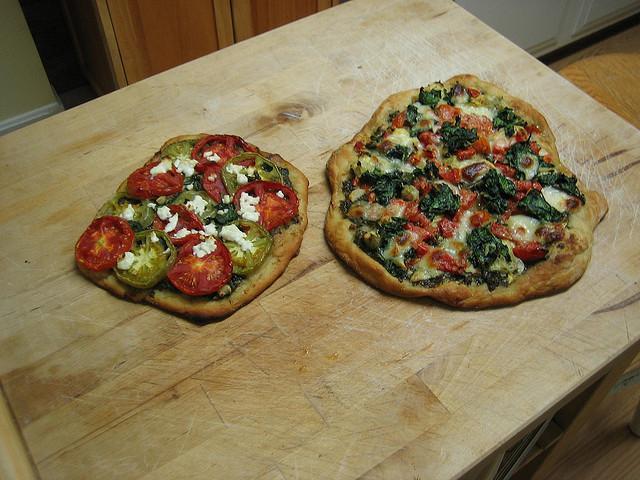How many different types of tomatoes are on the left pizza?
Give a very brief answer. 2. How many slices of tomatoes do you see?
Give a very brief answer. 7. How many pizzas are there?
Give a very brief answer. 2. How many men are in the back of the truck?
Give a very brief answer. 0. 